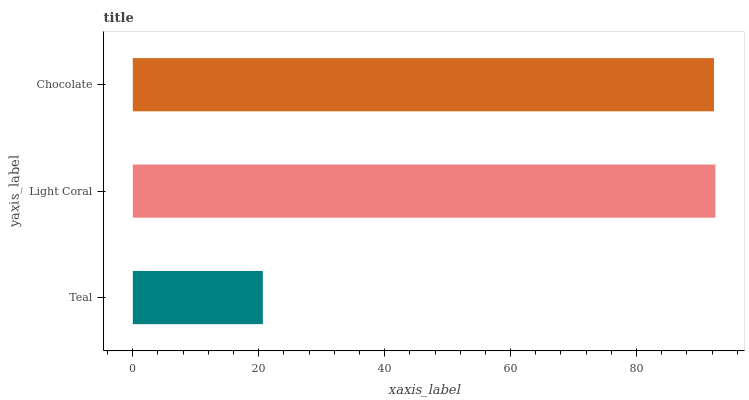Is Teal the minimum?
Answer yes or no. Yes. Is Light Coral the maximum?
Answer yes or no. Yes. Is Chocolate the minimum?
Answer yes or no. No. Is Chocolate the maximum?
Answer yes or no. No. Is Light Coral greater than Chocolate?
Answer yes or no. Yes. Is Chocolate less than Light Coral?
Answer yes or no. Yes. Is Chocolate greater than Light Coral?
Answer yes or no. No. Is Light Coral less than Chocolate?
Answer yes or no. No. Is Chocolate the high median?
Answer yes or no. Yes. Is Chocolate the low median?
Answer yes or no. Yes. Is Light Coral the high median?
Answer yes or no. No. Is Light Coral the low median?
Answer yes or no. No. 